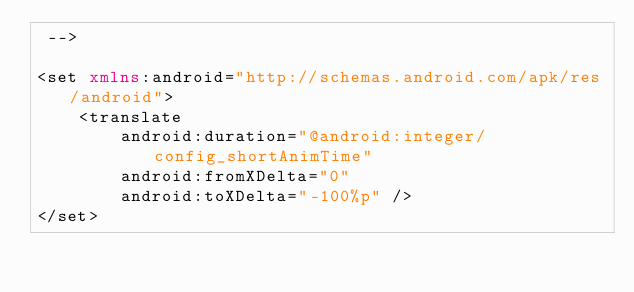<code> <loc_0><loc_0><loc_500><loc_500><_XML_> -->

<set xmlns:android="http://schemas.android.com/apk/res/android">
    <translate
        android:duration="@android:integer/config_shortAnimTime"
        android:fromXDelta="0"
        android:toXDelta="-100%p" />
</set></code> 